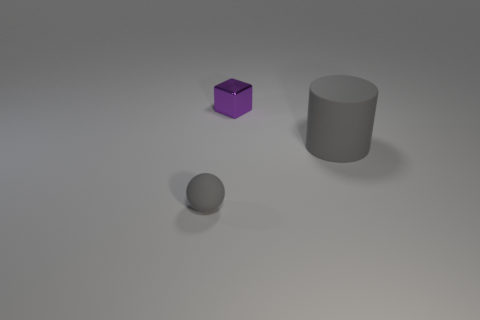Add 1 small brown matte things. How many objects exist? 4 Subtract all balls. How many objects are left? 2 Subtract 0 yellow balls. How many objects are left? 3 Subtract all big rubber cylinders. Subtract all tiny purple blocks. How many objects are left? 1 Add 2 small metal things. How many small metal things are left? 3 Add 1 purple shiny blocks. How many purple shiny blocks exist? 2 